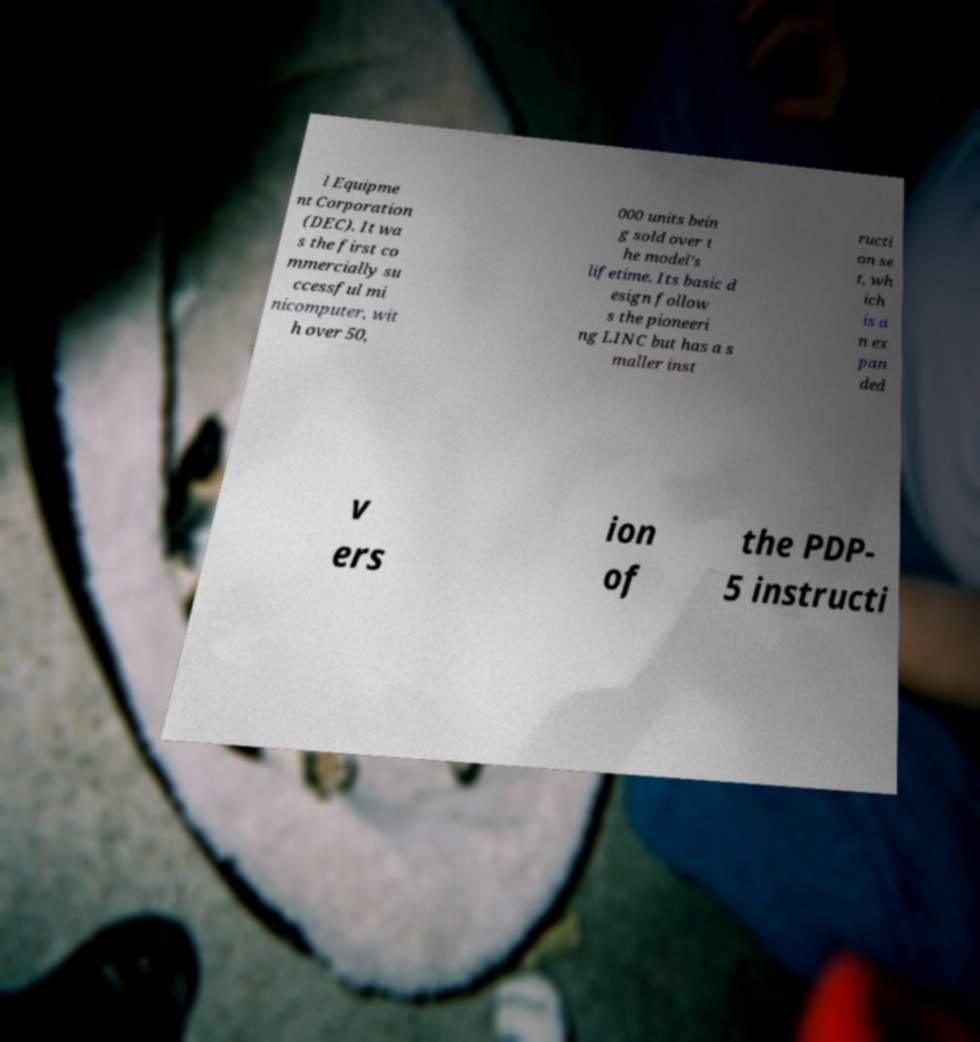For documentation purposes, I need the text within this image transcribed. Could you provide that? l Equipme nt Corporation (DEC). It wa s the first co mmercially su ccessful mi nicomputer, wit h over 50, 000 units bein g sold over t he model's lifetime. Its basic d esign follow s the pioneeri ng LINC but has a s maller inst ructi on se t, wh ich is a n ex pan ded v ers ion of the PDP- 5 instructi 